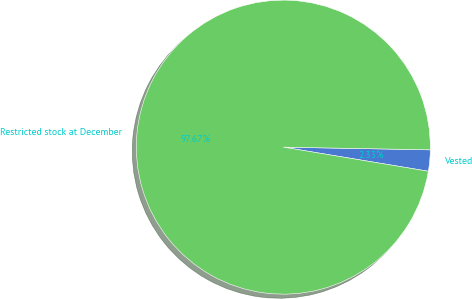Convert chart to OTSL. <chart><loc_0><loc_0><loc_500><loc_500><pie_chart><fcel>Vested<fcel>Restricted stock at December<nl><fcel>2.33%<fcel>97.67%<nl></chart> 